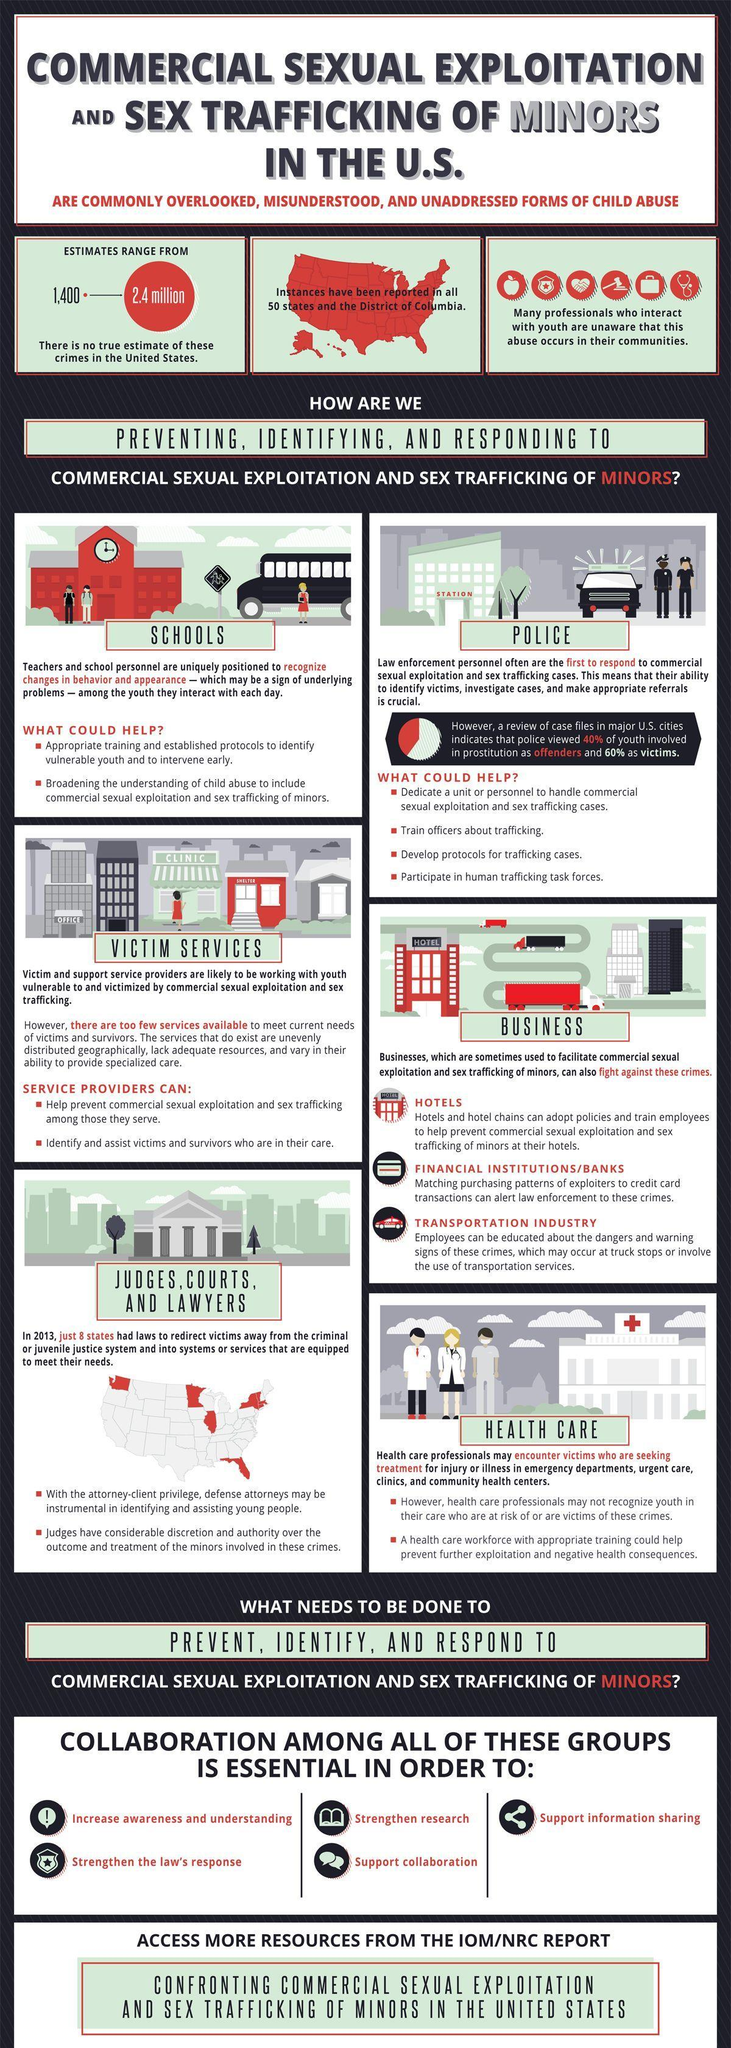What is the approximate estimate on trafficking in US?
Answer the question with a short phrase. 2.4 million 